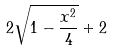<formula> <loc_0><loc_0><loc_500><loc_500>2 \sqrt { 1 - \frac { x ^ { 2 } } { 4 } } + 2</formula> 